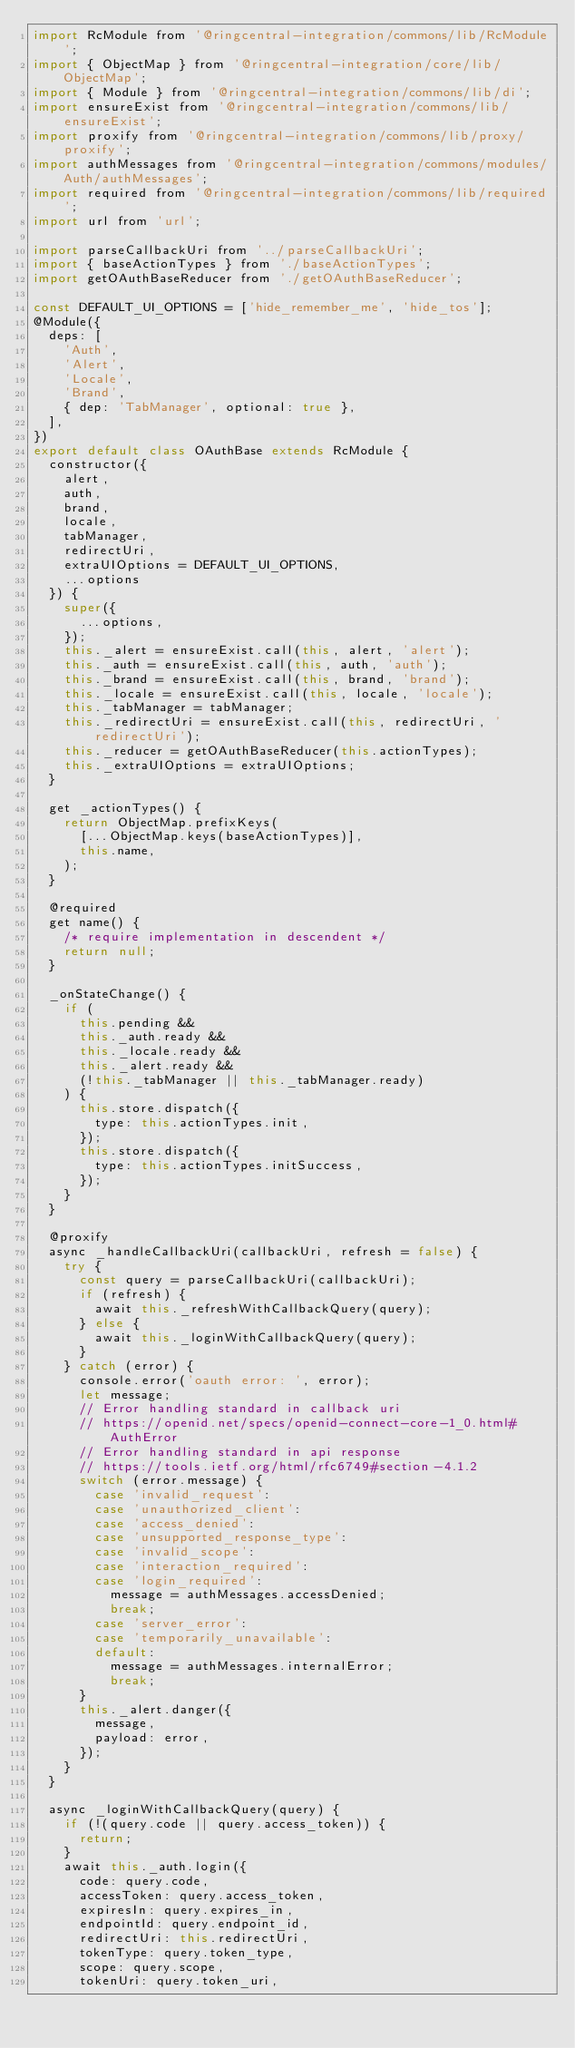Convert code to text. <code><loc_0><loc_0><loc_500><loc_500><_JavaScript_>import RcModule from '@ringcentral-integration/commons/lib/RcModule';
import { ObjectMap } from '@ringcentral-integration/core/lib/ObjectMap';
import { Module } from '@ringcentral-integration/commons/lib/di';
import ensureExist from '@ringcentral-integration/commons/lib/ensureExist';
import proxify from '@ringcentral-integration/commons/lib/proxy/proxify';
import authMessages from '@ringcentral-integration/commons/modules/Auth/authMessages';
import required from '@ringcentral-integration/commons/lib/required';
import url from 'url';

import parseCallbackUri from '../parseCallbackUri';
import { baseActionTypes } from './baseActionTypes';
import getOAuthBaseReducer from './getOAuthBaseReducer';

const DEFAULT_UI_OPTIONS = ['hide_remember_me', 'hide_tos'];
@Module({
  deps: [
    'Auth',
    'Alert',
    'Locale',
    'Brand',
    { dep: 'TabManager', optional: true },
  ],
})
export default class OAuthBase extends RcModule {
  constructor({
    alert,
    auth,
    brand,
    locale,
    tabManager,
    redirectUri,
    extraUIOptions = DEFAULT_UI_OPTIONS,
    ...options
  }) {
    super({
      ...options,
    });
    this._alert = ensureExist.call(this, alert, 'alert');
    this._auth = ensureExist.call(this, auth, 'auth');
    this._brand = ensureExist.call(this, brand, 'brand');
    this._locale = ensureExist.call(this, locale, 'locale');
    this._tabManager = tabManager;
    this._redirectUri = ensureExist.call(this, redirectUri, 'redirectUri');
    this._reducer = getOAuthBaseReducer(this.actionTypes);
    this._extraUIOptions = extraUIOptions;
  }

  get _actionTypes() {
    return ObjectMap.prefixKeys(
      [...ObjectMap.keys(baseActionTypes)],
      this.name,
    );
  }

  @required
  get name() {
    /* require implementation in descendent */
    return null;
  }

  _onStateChange() {
    if (
      this.pending &&
      this._auth.ready &&
      this._locale.ready &&
      this._alert.ready &&
      (!this._tabManager || this._tabManager.ready)
    ) {
      this.store.dispatch({
        type: this.actionTypes.init,
      });
      this.store.dispatch({
        type: this.actionTypes.initSuccess,
      });
    }
  }

  @proxify
  async _handleCallbackUri(callbackUri, refresh = false) {
    try {
      const query = parseCallbackUri(callbackUri);
      if (refresh) {
        await this._refreshWithCallbackQuery(query);
      } else {
        await this._loginWithCallbackQuery(query);
      }
    } catch (error) {
      console.error('oauth error: ', error);
      let message;
      // Error handling standard in callback uri
      // https://openid.net/specs/openid-connect-core-1_0.html#AuthError
      // Error handling standard in api response
      // https://tools.ietf.org/html/rfc6749#section-4.1.2
      switch (error.message) {
        case 'invalid_request':
        case 'unauthorized_client':
        case 'access_denied':
        case 'unsupported_response_type':
        case 'invalid_scope':
        case 'interaction_required':
        case 'login_required':
          message = authMessages.accessDenied;
          break;
        case 'server_error':
        case 'temporarily_unavailable':
        default:
          message = authMessages.internalError;
          break;
      }
      this._alert.danger({
        message,
        payload: error,
      });
    }
  }

  async _loginWithCallbackQuery(query) {
    if (!(query.code || query.access_token)) {
      return;
    }
    await this._auth.login({
      code: query.code,
      accessToken: query.access_token,
      expiresIn: query.expires_in,
      endpointId: query.endpoint_id,
      redirectUri: this.redirectUri,
      tokenType: query.token_type,
      scope: query.scope,
      tokenUri: query.token_uri,</code> 